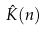Convert formula to latex. <formula><loc_0><loc_0><loc_500><loc_500>\hat { K } ( n )</formula> 